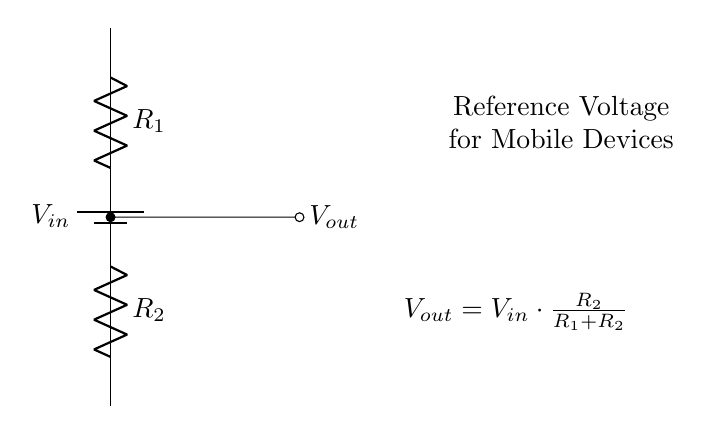What is the input voltage in the circuit? The input voltage, denoted as V_in, is represented as the positive terminal of the battery in the circuit diagram.
Answer: V_in What are the resistance values indicated in the diagram? The circuit shows two resistors: R_1 and R_2. Their values are not specified numerically but are labeled clearly in the diagram.
Answer: R_1, R_2 What is the formula for V_out in this circuit? The circuit diagram includes a mathematical expression detailing the output voltage calculation based on the resistances and input voltage, specifically: V_out = V_in * (R_2 / (R_1 + R_2)).
Answer: V_out = V_in * (R_2 / (R_1 + R_2)) How does increasing R_2 affect V_out? Increasing R_2 increases the fraction of R_2/(R_1 + R_2), which raises V_out since the output voltage is a proportion of the input voltage related to the resistor values.
Answer: V_out increases What role does this circuit play in mobile devices? This voltage divider circuit is used to create reference voltages, which are essential for operational tasks within battery-powered mobile devices, enabling them to function with the required voltage levels.
Answer: Reference voltages What would happen if R_1 is zero in this circuit? If R_1 is zero, the voltage divider effectively becomes a short circuit, leading to V_out directly equaling V_in since there is no resistance to share the voltage drop.
Answer: V_out = V_in 